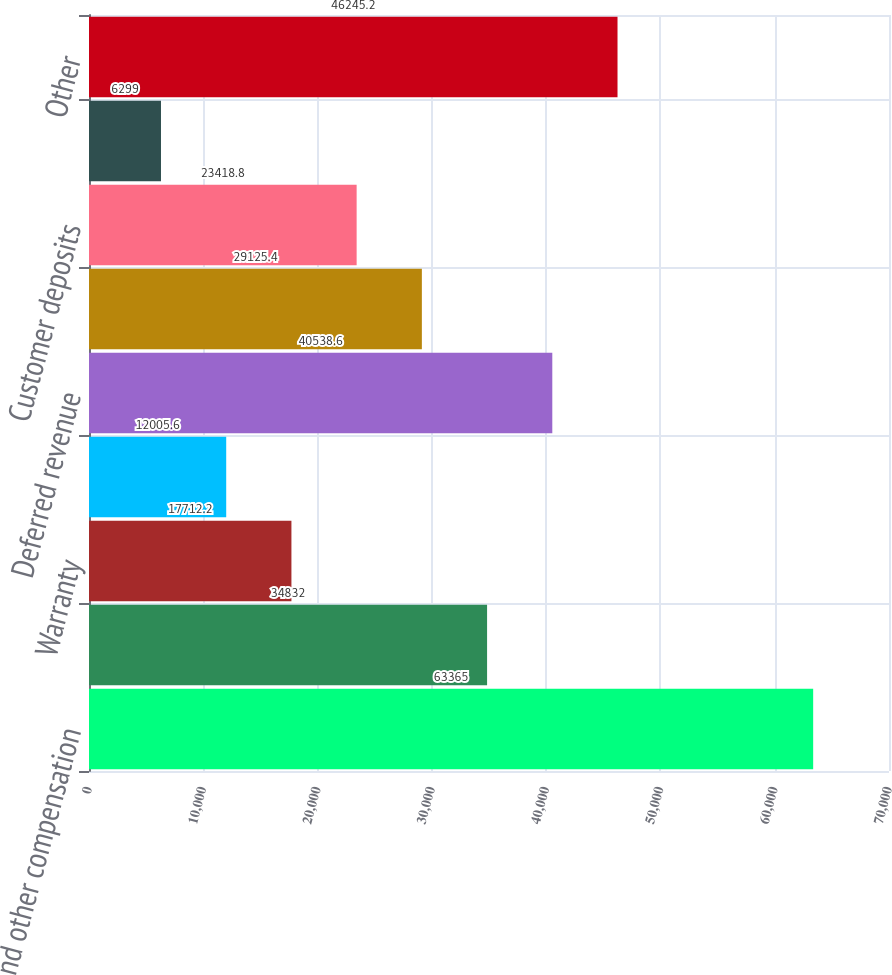<chart> <loc_0><loc_0><loc_500><loc_500><bar_chart><fcel>Wages and other compensation<fcel>Commissions<fcel>Warranty<fcel>Accrued dividend<fcel>Deferred revenue<fcel>Billings in excess of cost<fcel>Customer deposits<fcel>Interest<fcel>Other<nl><fcel>63365<fcel>34832<fcel>17712.2<fcel>12005.6<fcel>40538.6<fcel>29125.4<fcel>23418.8<fcel>6299<fcel>46245.2<nl></chart> 